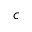Convert formula to latex. <formula><loc_0><loc_0><loc_500><loc_500>c</formula> 